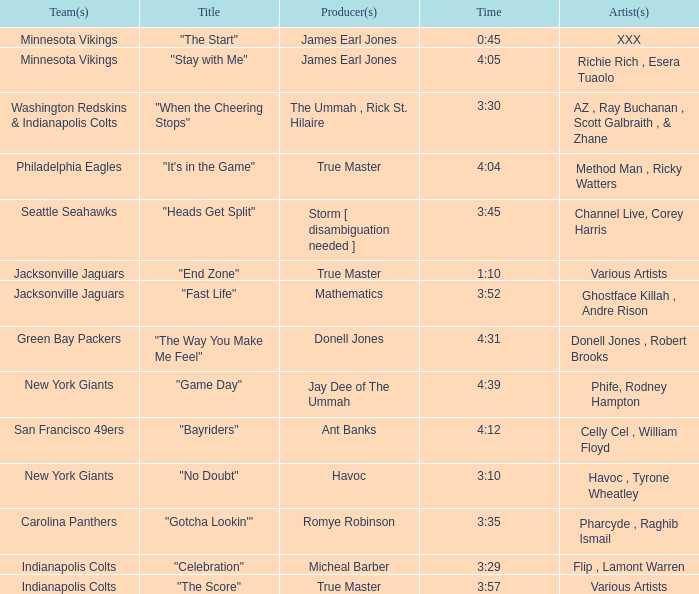Who is the artist of the Seattle Seahawks track? Channel Live, Corey Harris. 